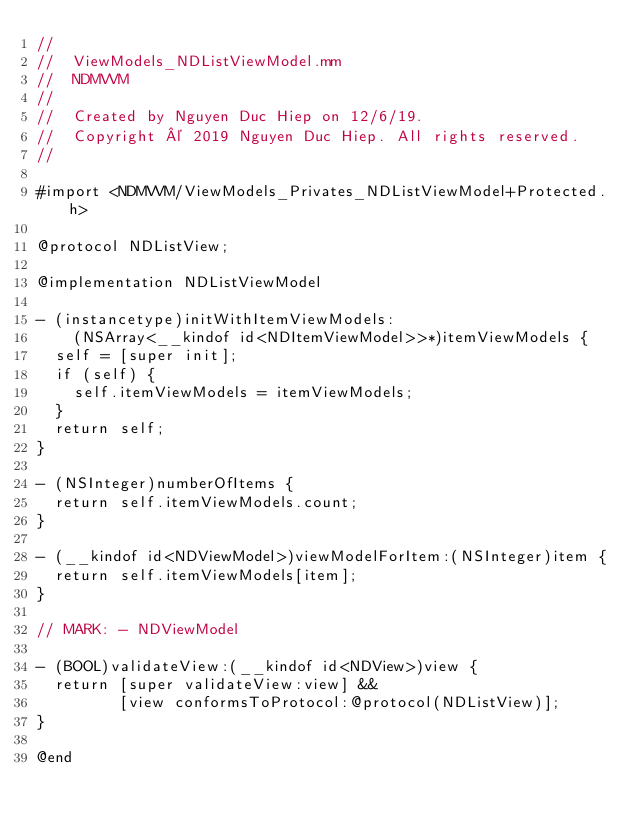Convert code to text. <code><loc_0><loc_0><loc_500><loc_500><_ObjectiveC_>//
//  ViewModels_NDListViewModel.mm
//  NDMVVM
//
//  Created by Nguyen Duc Hiep on 12/6/19.
//  Copyright © 2019 Nguyen Duc Hiep. All rights reserved.
//

#import <NDMVVM/ViewModels_Privates_NDListViewModel+Protected.h>

@protocol NDListView;

@implementation NDListViewModel

- (instancetype)initWithItemViewModels:
    (NSArray<__kindof id<NDItemViewModel>>*)itemViewModels {
  self = [super init];
  if (self) {
    self.itemViewModels = itemViewModels;
  }
  return self;
}

- (NSInteger)numberOfItems {
  return self.itemViewModels.count;
}

- (__kindof id<NDViewModel>)viewModelForItem:(NSInteger)item {
  return self.itemViewModels[item];
}

// MARK: - NDViewModel

- (BOOL)validateView:(__kindof id<NDView>)view {
  return [super validateView:view] &&
         [view conformsToProtocol:@protocol(NDListView)];
}

@end
</code> 